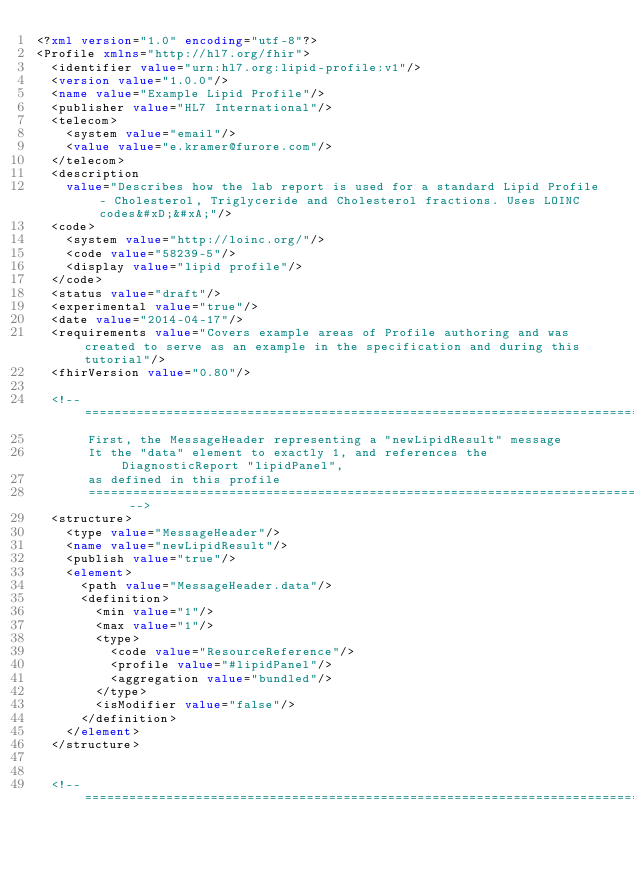Convert code to text. <code><loc_0><loc_0><loc_500><loc_500><_XML_><?xml version="1.0" encoding="utf-8"?>
<Profile xmlns="http://hl7.org/fhir">
  <identifier value="urn:hl7.org:lipid-profile:v1"/>
  <version value="1.0.0"/>
  <name value="Example Lipid Profile"/>
  <publisher value="HL7 International"/>
  <telecom>
    <system value="email"/>
    <value value="e.kramer@furore.com"/>
  </telecom>
  <description
    value="Describes how the lab report is used for a standard Lipid Profile - Cholesterol, Triglyceride and Cholesterol fractions. Uses LOINC codes&#xD;&#xA;"/>
  <code>
    <system value="http://loinc.org/"/>
    <code value="58239-5"/>
    <display value="lipid profile"/>
  </code>
  <status value="draft"/>
  <experimental value="true"/>
  <date value="2014-04-17"/>
  <requirements value="Covers example areas of Profile authoring and was created to serve as an example in the specification and during this tutorial"/>
  <fhirVersion value="0.80"/>

  <!-- ====================================================================================
       First, the MessageHeader representing a "newLipidResult" message      
       It the "data" element to exactly 1, and references the DiagnosticReport "lipidPanel", 
       as defined in this profile
       ==================================================================================== -->
  <structure>
    <type value="MessageHeader"/>
    <name value="newLipidResult"/>
    <publish value="true"/>
    <element>
      <path value="MessageHeader.data"/>
      <definition>
        <min value="1"/>
        <max value="1"/>
        <type>
          <code value="ResourceReference"/>
          <profile value="#lipidPanel"/>
          <aggregation value="bundled"/>
        </type>
        <isModifier value="false"/>
      </definition>
    </element>
  </structure>


  <!-- ====================================================================================</code> 